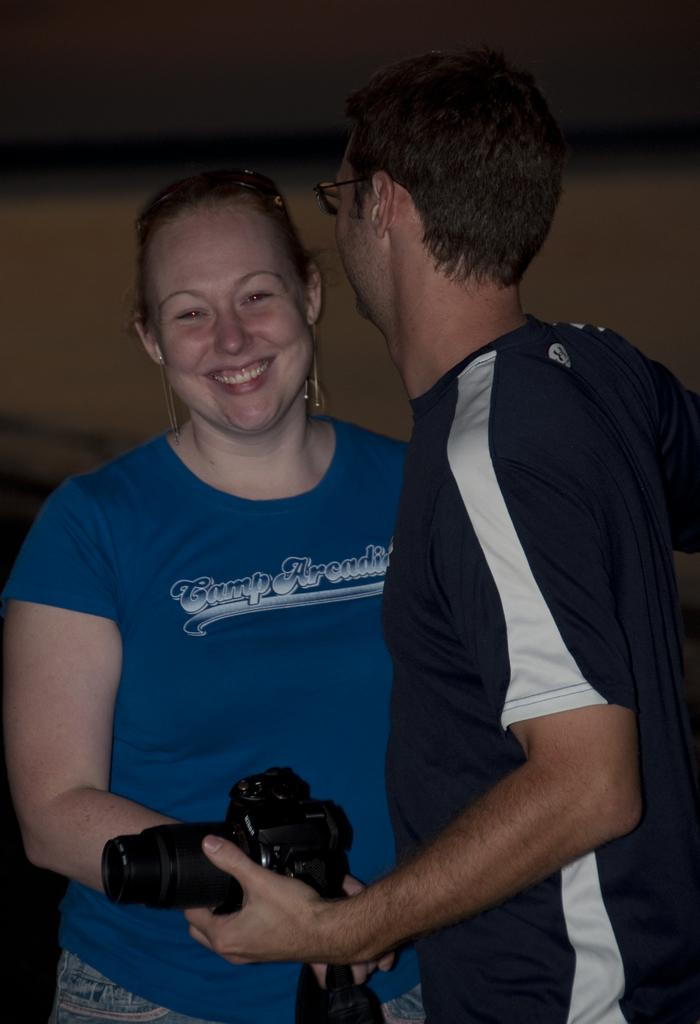How many people are in the image? There are two persons in the image. Can you describe the gender of each person? One person is a man, and the other person is a woman. What is the man holding in the image? The man is holding a camera. How is the woman's expression in the image? The woman is smiling. What type of nation is depicted in the image? There is no nation depicted in the image; it features two people, one person, a man and a woman. Can you tell me how many zippers are visible on the woman's clothing in the image? There is no zipper visible on the woman's clothing in the image. 